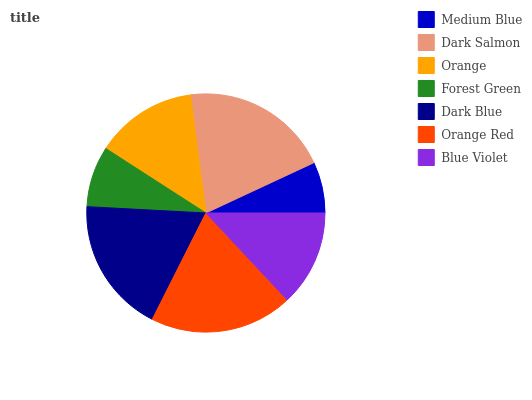Is Medium Blue the minimum?
Answer yes or no. Yes. Is Dark Salmon the maximum?
Answer yes or no. Yes. Is Orange the minimum?
Answer yes or no. No. Is Orange the maximum?
Answer yes or no. No. Is Dark Salmon greater than Orange?
Answer yes or no. Yes. Is Orange less than Dark Salmon?
Answer yes or no. Yes. Is Orange greater than Dark Salmon?
Answer yes or no. No. Is Dark Salmon less than Orange?
Answer yes or no. No. Is Orange the high median?
Answer yes or no. Yes. Is Orange the low median?
Answer yes or no. Yes. Is Orange Red the high median?
Answer yes or no. No. Is Orange Red the low median?
Answer yes or no. No. 